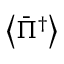<formula> <loc_0><loc_0><loc_500><loc_500>\left \langle { { { \bar { \Pi } } ^ { \dag } } } \right \rangle</formula> 